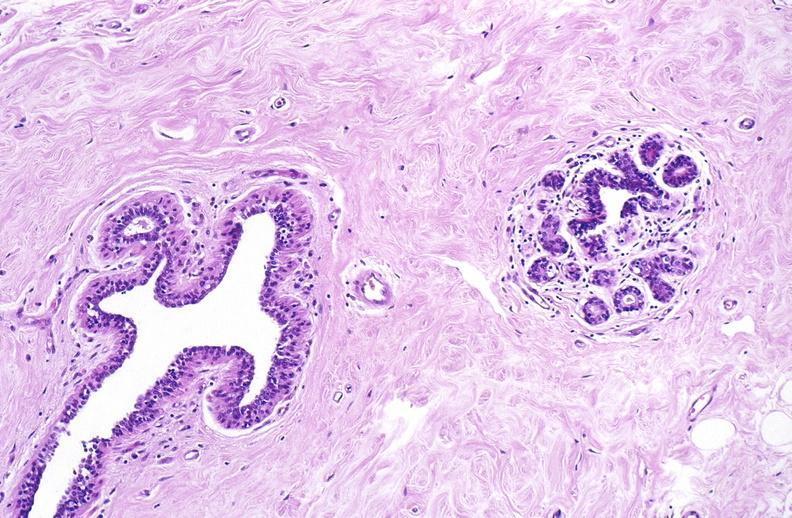does surface show normal breast?
Answer the question using a single word or phrase. No 